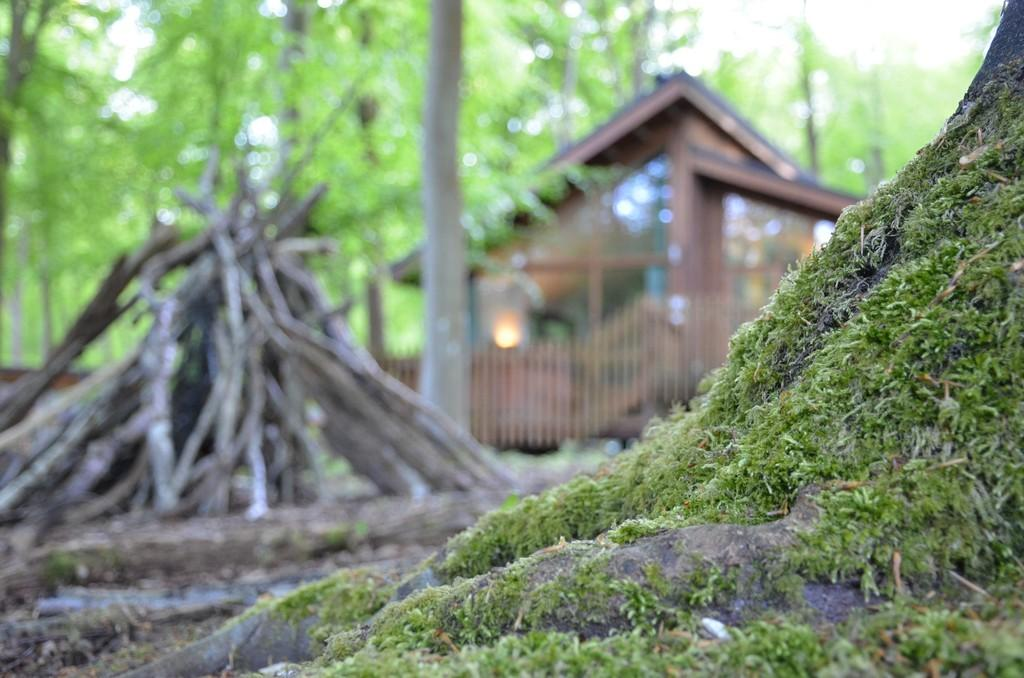Where was the image taken? The image was taken outside. What type of vegetation is visible at the bottom of the image? There is grass at the bottom of the image near a tree. What objects can be seen on the left side of the image? There are wooden sticks on the left side of the image. What structures are visible in the background of the image? There is a house and many trees in the background of the image. What type of bean is being cooked by the band in the image? There is no bean or band present in the image. What type of support is being used by the trees in the image? The trees in the image do not require any support; they are standing on their own. 